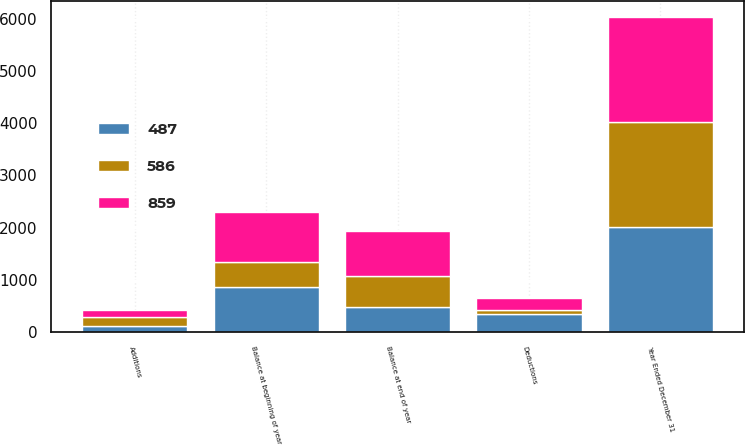Convert chart to OTSL. <chart><loc_0><loc_0><loc_500><loc_500><stacked_bar_chart><ecel><fcel>Year Ended December 31<fcel>Balance at beginning of year<fcel>Additions<fcel>Deductions<fcel>Balance at end of year<nl><fcel>586<fcel>2013<fcel>487<fcel>169<fcel>70<fcel>586<nl><fcel>487<fcel>2012<fcel>859<fcel>126<fcel>352<fcel>487<nl><fcel>859<fcel>2011<fcel>950<fcel>138<fcel>229<fcel>859<nl></chart> 